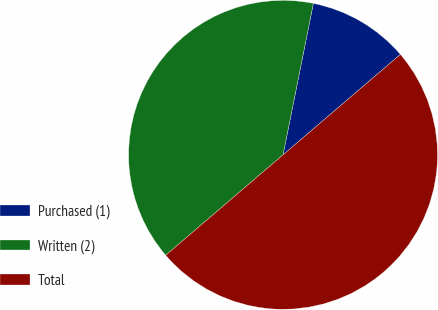<chart> <loc_0><loc_0><loc_500><loc_500><pie_chart><fcel>Purchased (1)<fcel>Written (2)<fcel>Total<nl><fcel>10.59%<fcel>39.41%<fcel>50.0%<nl></chart> 